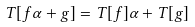<formula> <loc_0><loc_0><loc_500><loc_500>T [ f \alpha + g ] = T [ f ] \alpha + T [ g ]</formula> 